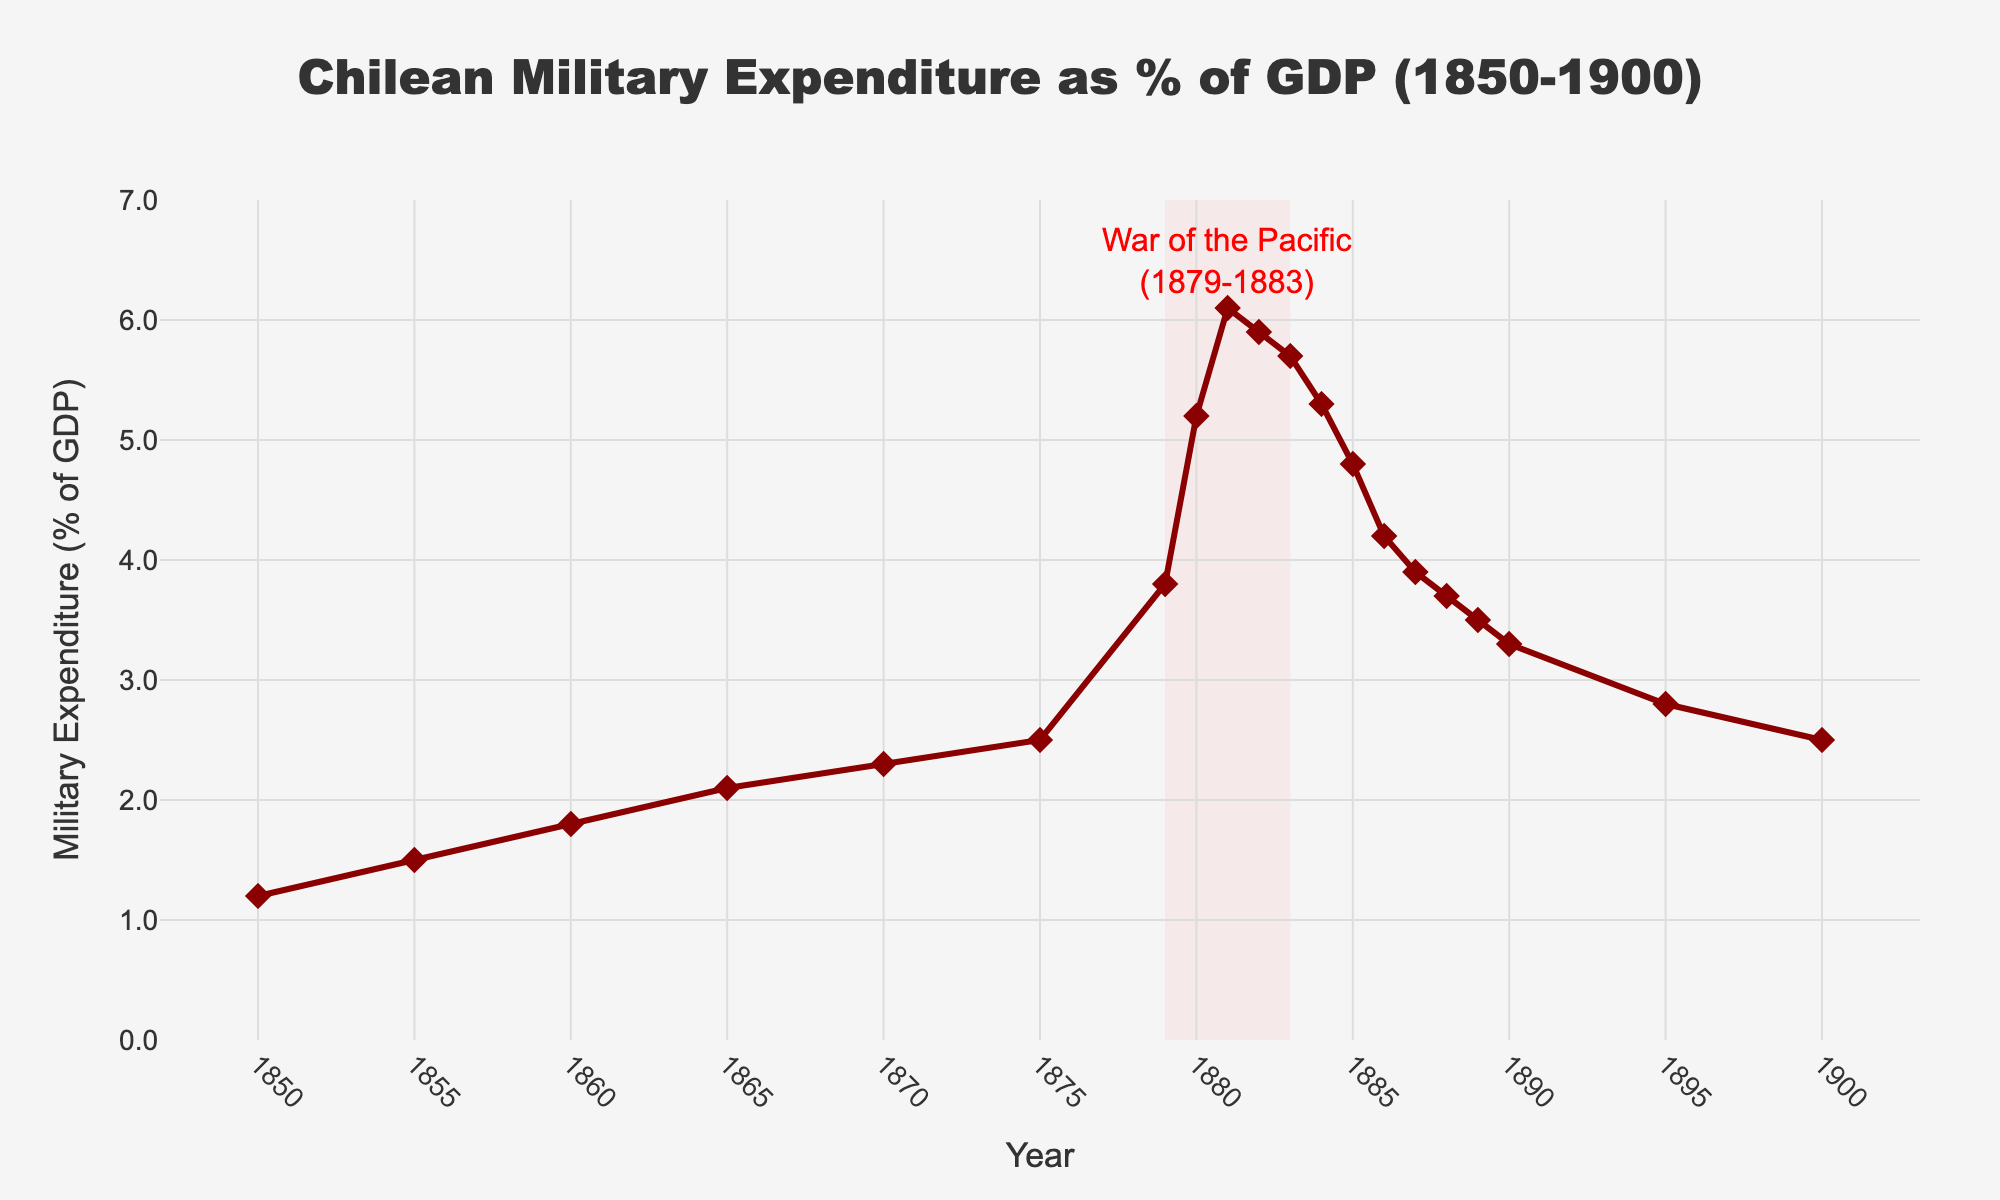1. What year saw the highest military expenditure as a percentage of GDP? To find the highest military expenditure as a percentage of GDP, look for the peak point in the line chart. The highest point appears to be in 1881 with a value of 6.1%.
Answer: 1881 2. How did the military expenditure percentage change from 1879 to 1883 during the War of the Pacific? To determine the change, observe the values in 1879 and 1883 and then subtract the latter from the former. The percentage increased from 3.8% in 1879 to 5.7% in 1883.
Answer: Increased by 1.9% 3. What is the difference in military expenditure as a percentage of GDP between 1850 and 1900? Note the values for 1850 and 1900 on the y-axis. Subtract the 1850 value (1.2%) from the 1900 value (2.5%).
Answer: 1.3% 4. Which years show a decline in military expenditure percentage following the peak in 1881? Identify the years after 1881 where the line slope is negative. The values decline from 1882 to 1885.
Answer: 1882, 1883, 1884, 1885 5. What was the trend in military expenditure percentage during the 1860s? Look at the line chart from 1860 to 1870. From 1860 (1.8%) to 1865 (2.1%) and then to 1870 (2.3%), the trend shows a gradual increase.
Answer: Increasing 6. Compared to 1865, what was the percentage increase in military expenditure by 1880? Calculate the percentage increase: ((5.2% - 2.1%) / 2.1%) * 100. This results in approximately a 147.62% increase.
Answer: 147.62% 7. What visual element highlights the War of the Pacific period? Identify the chart element that specifically marks the War of the Pacific. The period is highlighted by a shaded rectangle from 1879 to 1883 with an annotation at 1881.
Answer: Shaded rectangle and annotation 8. Comparing 1875 and 1885, which year had a higher military expenditure percentage and by how much? Compare the values in 1875 (2.5%) and 1885 (4.8%). The difference is 4.8% - 2.5% = 2.3%.
Answer: 1885 by 2.3% 9. What is the trend in military expenditure percentage after the War of the Pacific until 1900? Examine the line chart from 1884 to 1900. The trend shows a steady decline from 5.3% in 1884 to 2.5% in 1900.
Answer: Decreasing 10. What was the average military expenditure as a percentage of GDP during the War of the Pacific (1879-1883)? Add the percentages for 1879 (3.8%), 1880 (5.2%), 1881 (6.1%), 1882 (5.9%), and 1883 (5.7%) and divide by 5. The total is 26.7%, so the average is 26.7% / 5 = 5.34%.
Answer: 5.34% 